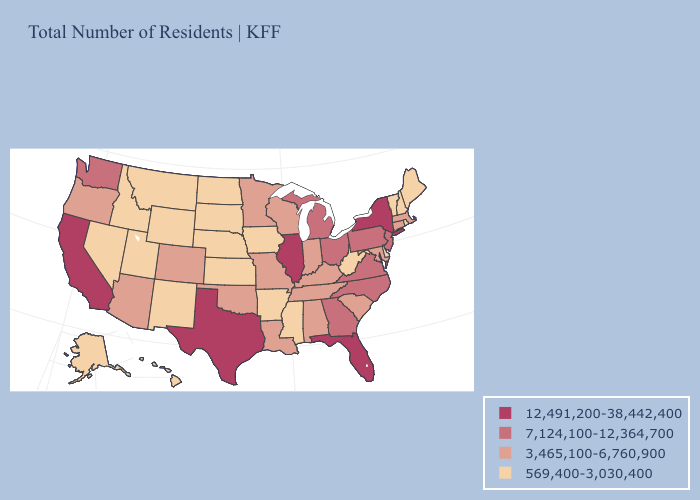Is the legend a continuous bar?
Short answer required. No. What is the value of Oregon?
Concise answer only. 3,465,100-6,760,900. Which states have the highest value in the USA?
Short answer required. California, Florida, Illinois, New York, Texas. Does Oklahoma have the highest value in the USA?
Short answer required. No. Name the states that have a value in the range 3,465,100-6,760,900?
Short answer required. Alabama, Arizona, Colorado, Connecticut, Indiana, Kentucky, Louisiana, Maryland, Massachusetts, Minnesota, Missouri, Oklahoma, Oregon, South Carolina, Tennessee, Wisconsin. What is the lowest value in states that border Washington?
Concise answer only. 569,400-3,030,400. What is the value of Wyoming?
Concise answer only. 569,400-3,030,400. What is the value of Kansas?
Write a very short answer. 569,400-3,030,400. What is the value of Hawaii?
Quick response, please. 569,400-3,030,400. What is the value of Washington?
Keep it brief. 7,124,100-12,364,700. What is the value of Texas?
Short answer required. 12,491,200-38,442,400. Does California have the lowest value in the West?
Write a very short answer. No. Name the states that have a value in the range 3,465,100-6,760,900?
Write a very short answer. Alabama, Arizona, Colorado, Connecticut, Indiana, Kentucky, Louisiana, Maryland, Massachusetts, Minnesota, Missouri, Oklahoma, Oregon, South Carolina, Tennessee, Wisconsin. Name the states that have a value in the range 12,491,200-38,442,400?
Short answer required. California, Florida, Illinois, New York, Texas. What is the value of Nevada?
Keep it brief. 569,400-3,030,400. 